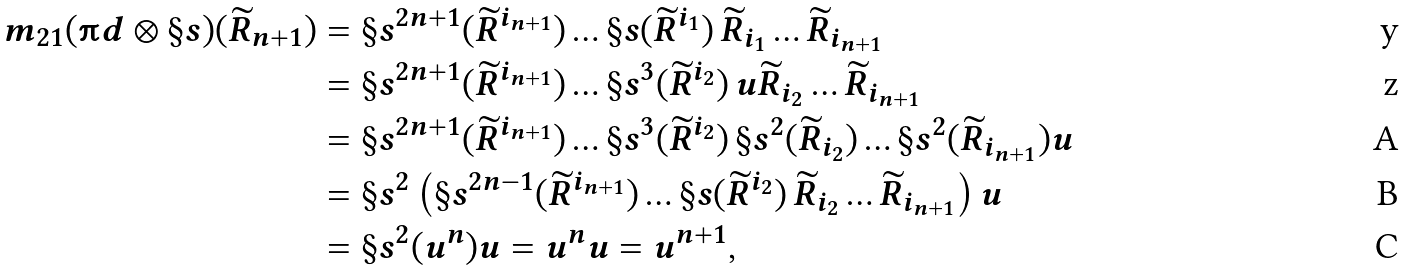<formula> <loc_0><loc_0><loc_500><loc_500>m _ { 2 1 } ( \i d \otimes \S s ) ( \widetilde { R } _ { n + 1 } ) & = \S s ^ { 2 n + 1 } ( \widetilde { R } ^ { i _ { n + 1 } } ) \dots \S s ( \widetilde { R } ^ { i _ { 1 } } ) \, \widetilde { R } _ { i _ { 1 } } \dots \widetilde { R } _ { i _ { n + 1 } } \\ & = \S s ^ { 2 n + 1 } ( \widetilde { R } ^ { i _ { n + 1 } } ) \dots \S s ^ { 3 } ( \widetilde { R } ^ { i _ { 2 } } ) \, u \widetilde { R } _ { i _ { 2 } } \dots \widetilde { R } _ { i _ { n + 1 } } \\ & = \S s ^ { 2 n + 1 } ( \widetilde { R } ^ { i _ { n + 1 } } ) \dots \S s ^ { 3 } ( \widetilde { R } ^ { i _ { 2 } } ) \, \S s ^ { 2 } ( \widetilde { R } _ { i _ { 2 } } ) \dots \S s ^ { 2 } ( \widetilde { R } _ { i _ { n + 1 } } ) u \\ & = \S s ^ { 2 } \left ( \S s ^ { 2 n - 1 } ( \widetilde { R } ^ { i _ { n + 1 } } ) \dots \S s ( \widetilde { R } ^ { i _ { 2 } } ) \, \widetilde { R } _ { i _ { 2 } } \dots \widetilde { R } _ { i _ { n + 1 } } \right ) u \\ & = \S s ^ { 2 } ( u ^ { n } ) u = u ^ { n } u = u ^ { n + 1 } ,</formula> 